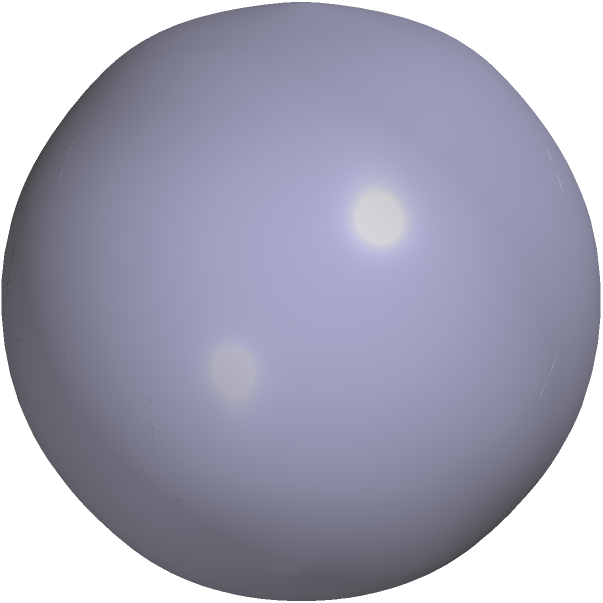As the CEO of a quantum computing corporation, you're reviewing a new qubit state representation. The diagram shows a Bloch sphere with a qubit state $|\psi\rangle$. Given that the state vector makes equal angles with the $|0\rangle$ and $|+\rangle$ basis states, what is the normalized state vector $|\psi\rangle$ in terms of $|0\rangle$ and $|1\rangle$? Let's approach this step-by-step:

1) The Bloch sphere represents pure qubit states. The north pole represents $|0\rangle$, and the south pole represents $|1\rangle$.

2) The $|+\rangle$ state is on the positive x-axis and is defined as $|+\rangle = \frac{1}{\sqrt{2}}(|0\rangle + |1\rangle)$.

3) The state $|\psi\rangle$ makes equal angles with $|0\rangle$ and $|+\rangle$. This means it's halfway between these two states on the Bloch sphere.

4) To be halfway between $|0\rangle$ and $|+\rangle$, the state must be of the form:

   $|\psi\rangle = \cos(\frac{\pi}{8})|0\rangle + e^{i\phi}\sin(\frac{\pi}{8})|1\rangle$

   where $\phi$ is some phase factor.

5) Since the state is in the xz-plane (no y-component visible), we know that $e^{i\phi} = 1$.

6) Therefore, our state is:

   $|\psi\rangle = \cos(\frac{\pi}{8})|0\rangle + \sin(\frac{\pi}{8})|1\rangle$

7) We can simplify this using the following trigonometric identities:

   $\cos(\frac{\pi}{8}) = \frac{\sqrt{2+\sqrt{2}}}{2}$
   $\sin(\frac{\pi}{8}) = \frac{\sqrt{2-\sqrt{2}}}{2}$

8) Substituting these in, we get our final normalized state vector:

   $|\psi\rangle = \frac{\sqrt{2+\sqrt{2}}}{2}|0\rangle + \frac{\sqrt{2-\sqrt{2}}}{2}|1\rangle$
Answer: $|\psi\rangle = \frac{\sqrt{2+\sqrt{2}}}{2}|0\rangle + \frac{\sqrt{2-\sqrt{2}}}{2}|1\rangle$ 